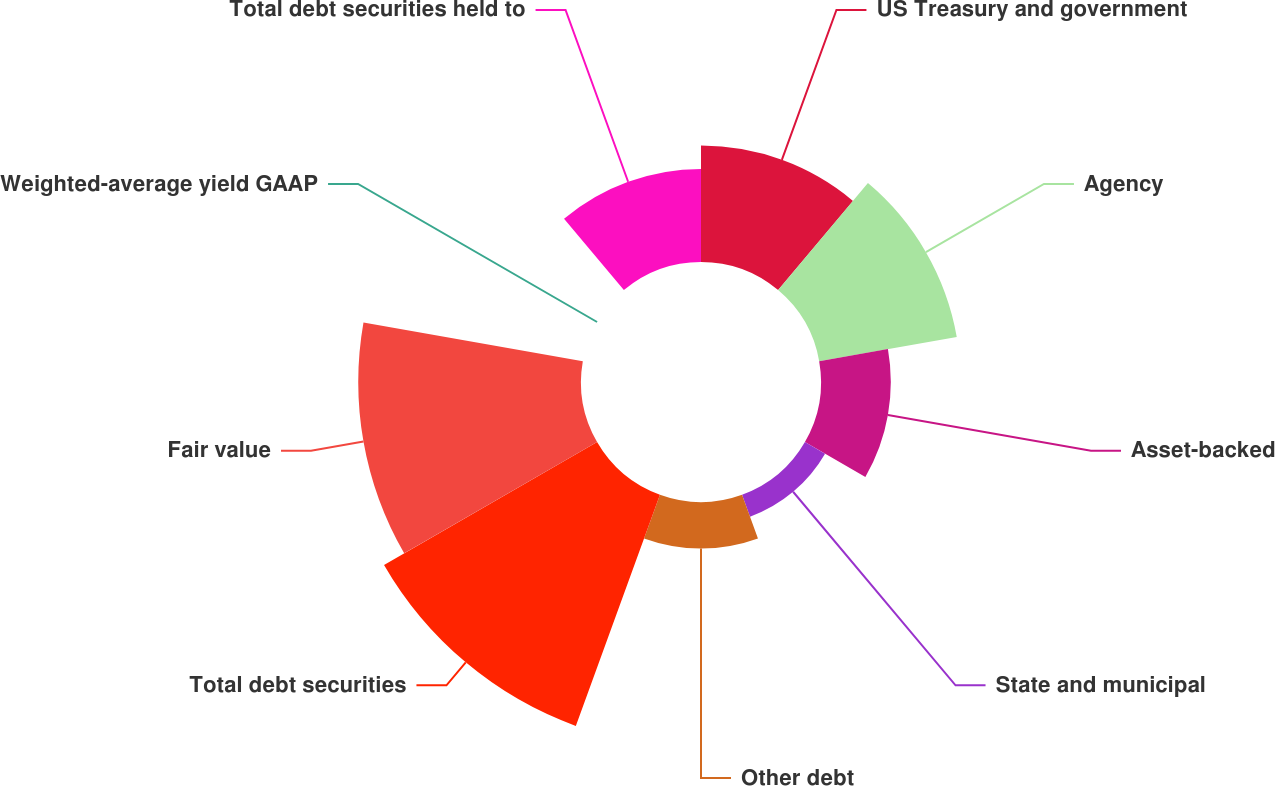Convert chart to OTSL. <chart><loc_0><loc_0><loc_500><loc_500><pie_chart><fcel>US Treasury and government<fcel>Agency<fcel>Asset-backed<fcel>State and municipal<fcel>Other debt<fcel>Total debt securities<fcel>Fair value<fcel>Weighted-average yield GAAP<fcel>Total debt securities held to<nl><fcel>12.16%<fcel>14.59%<fcel>7.29%<fcel>2.43%<fcel>4.86%<fcel>25.69%<fcel>23.26%<fcel>0.0%<fcel>9.72%<nl></chart> 